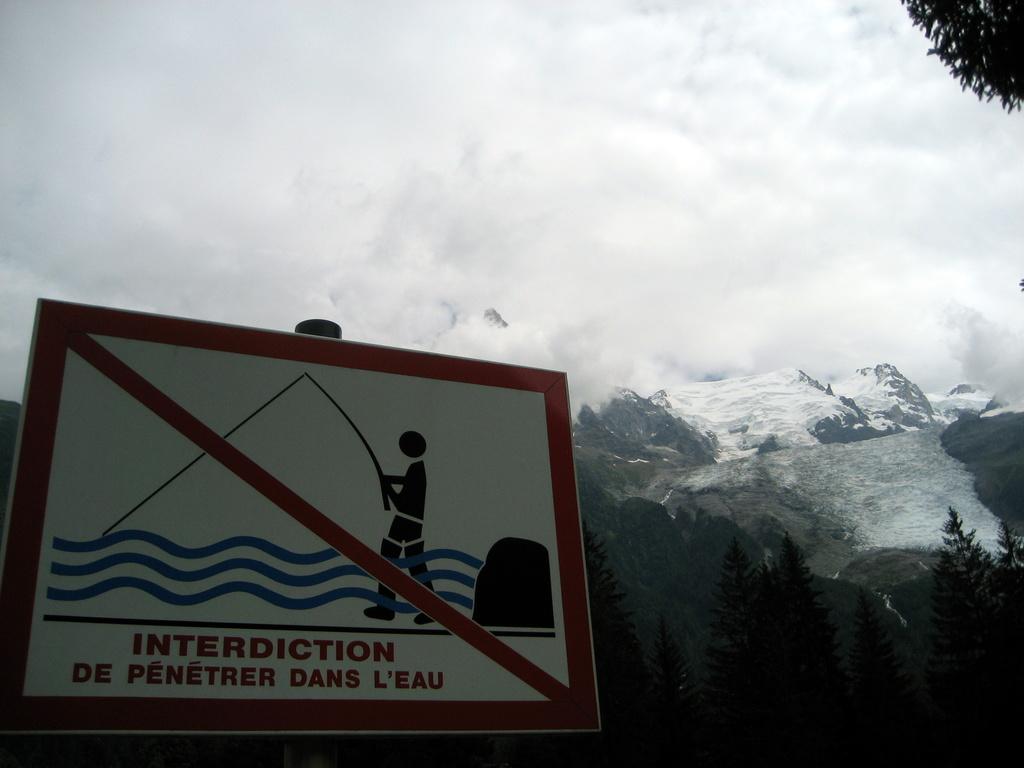What does the sign say?
Keep it short and to the point. Interdiction de penetrer dans l'eau. 